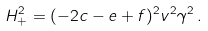Convert formula to latex. <formula><loc_0><loc_0><loc_500><loc_500>H _ { + } ^ { 2 } = ( - 2 c - e + f ) ^ { 2 } v ^ { 2 } \gamma ^ { 2 } \, .</formula> 